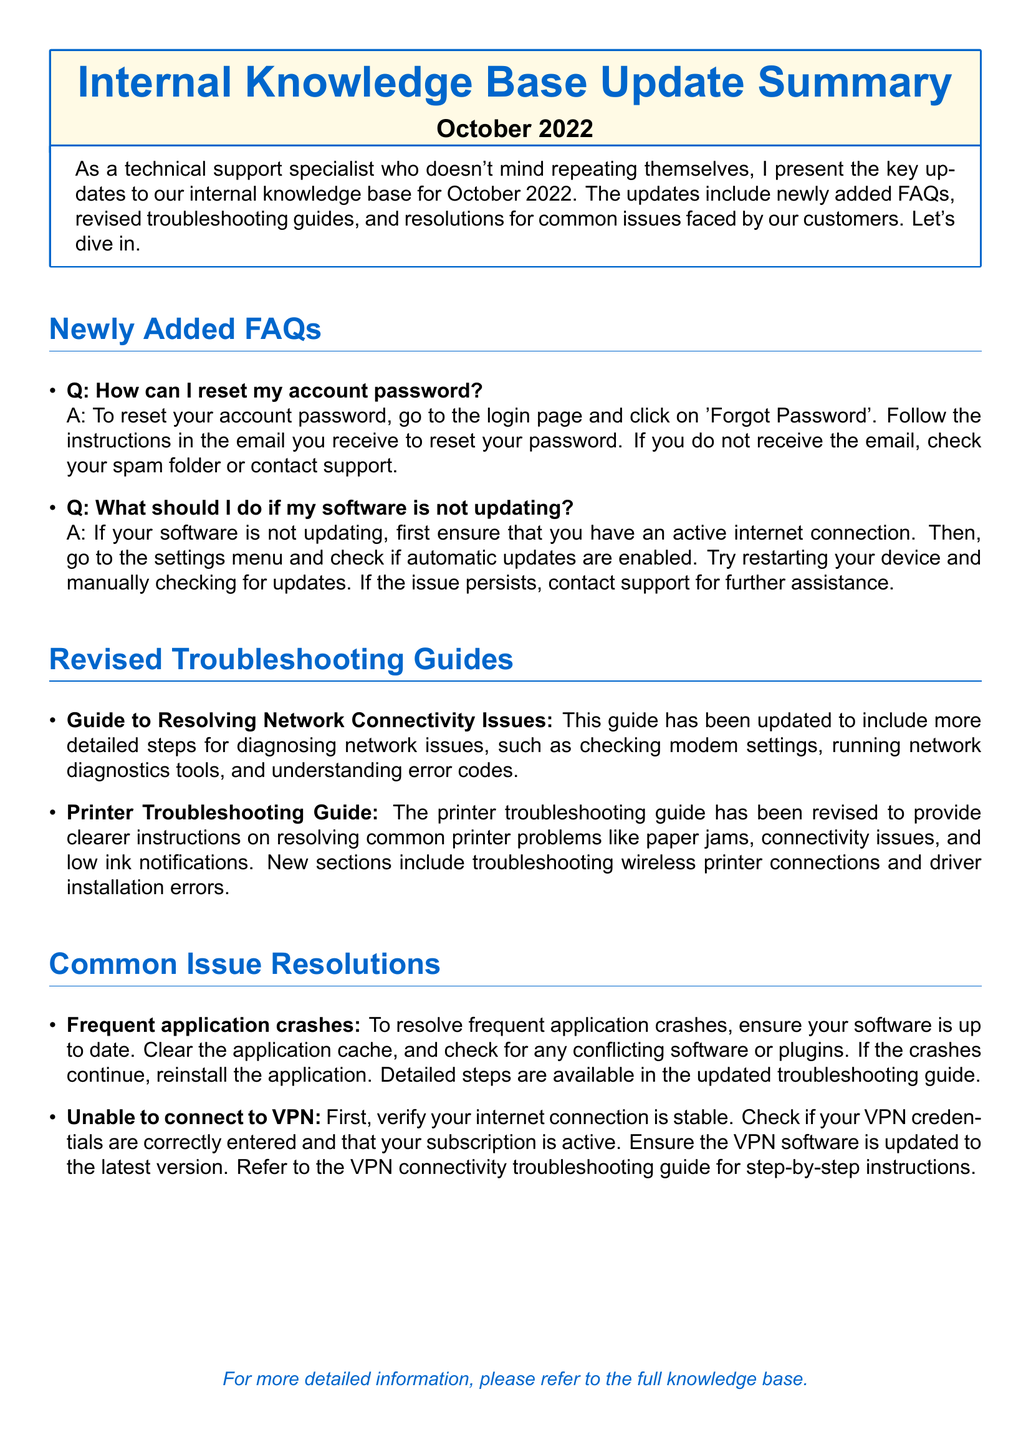What month is this update for? The document specifies that the update is for October 2022.
Answer: October 2022 How can I reset my account password? The FAQ provides a detailed method to reset an account password.
Answer: Click on 'Forgot Password' What guide was updated regarding network issues? The document mentions a specific guide related to network connectivity challenges.
Answer: Guide to Resolving Network Connectivity Issues What issue is addressed in the common resolutions section? The document lists issues often faced by users, including those related to applications.
Answer: Frequent application crashes What should you do if your software is not updating? The FAQ outlines initial steps to take when software updates are not occurring.
Answer: Ensure an active internet connection 